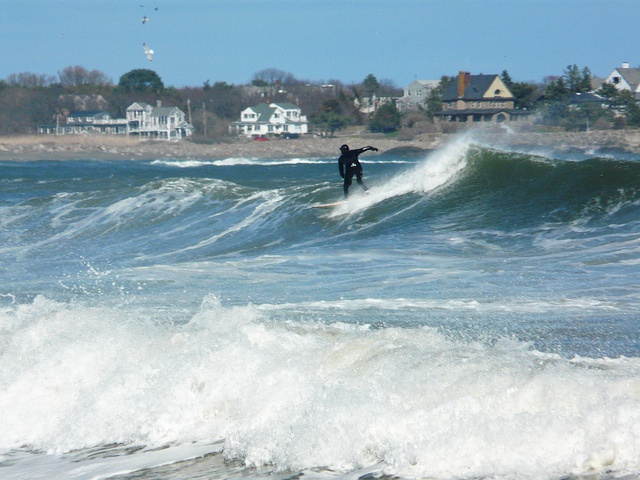Describe the objects in this image and their specific colors. I can see people in lightblue, black, gray, blue, and navy tones, surfboard in lightblue, darkgray, gray, and lightgray tones, car in lightblue, blue, and gray tones, and car in lightblue, brown, gray, darkgray, and purple tones in this image. 